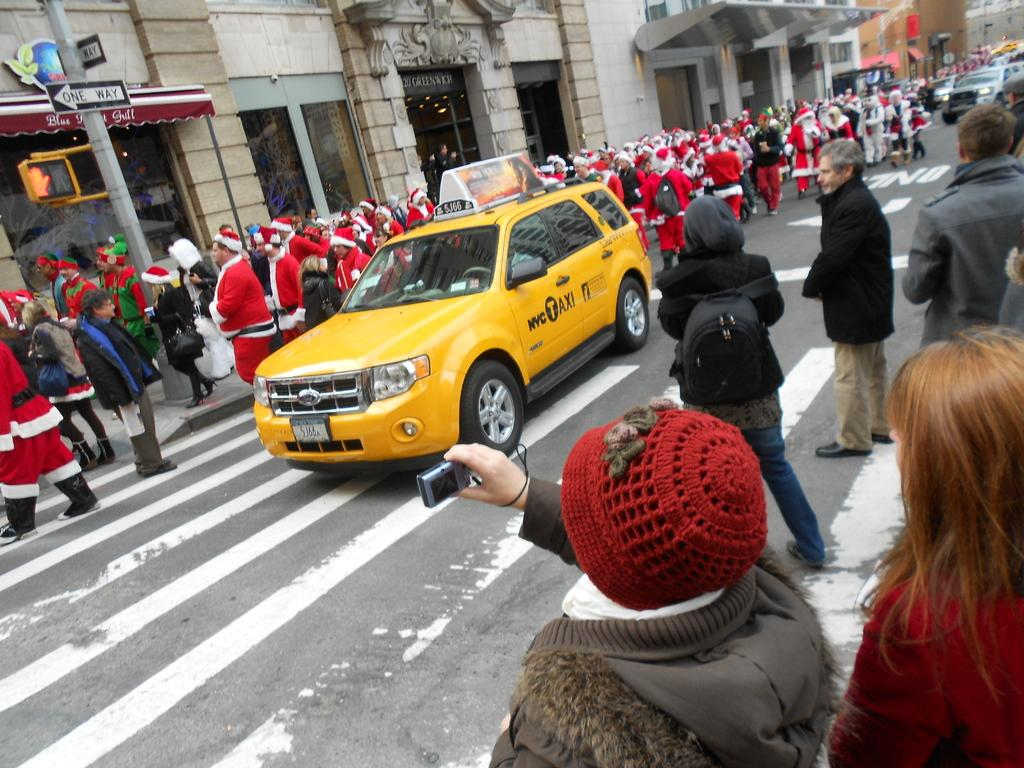Provide a one-sentence caption for the provided image. a busy street with a nyc taxi cab in the middle. 